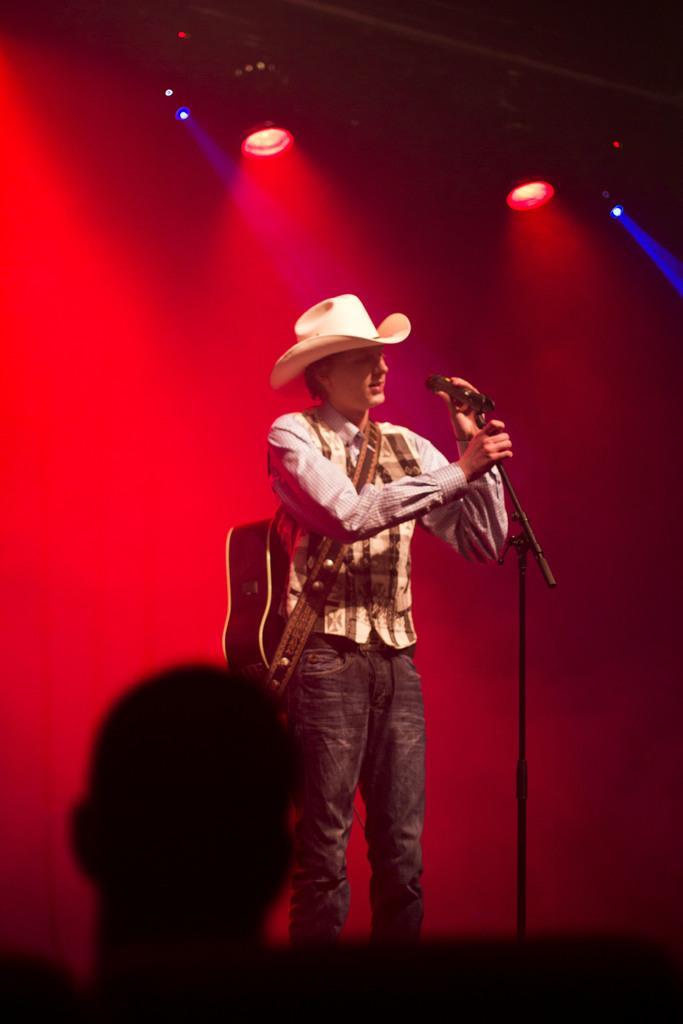In one or two sentences, can you explain what this image depicts? In this image in the middle there is one Person who is standing and he is wearing a guitar and he is also wearing a cap in front of him there is one mike and on the background there are some lights and in the bottom of the left corner there is another person. 